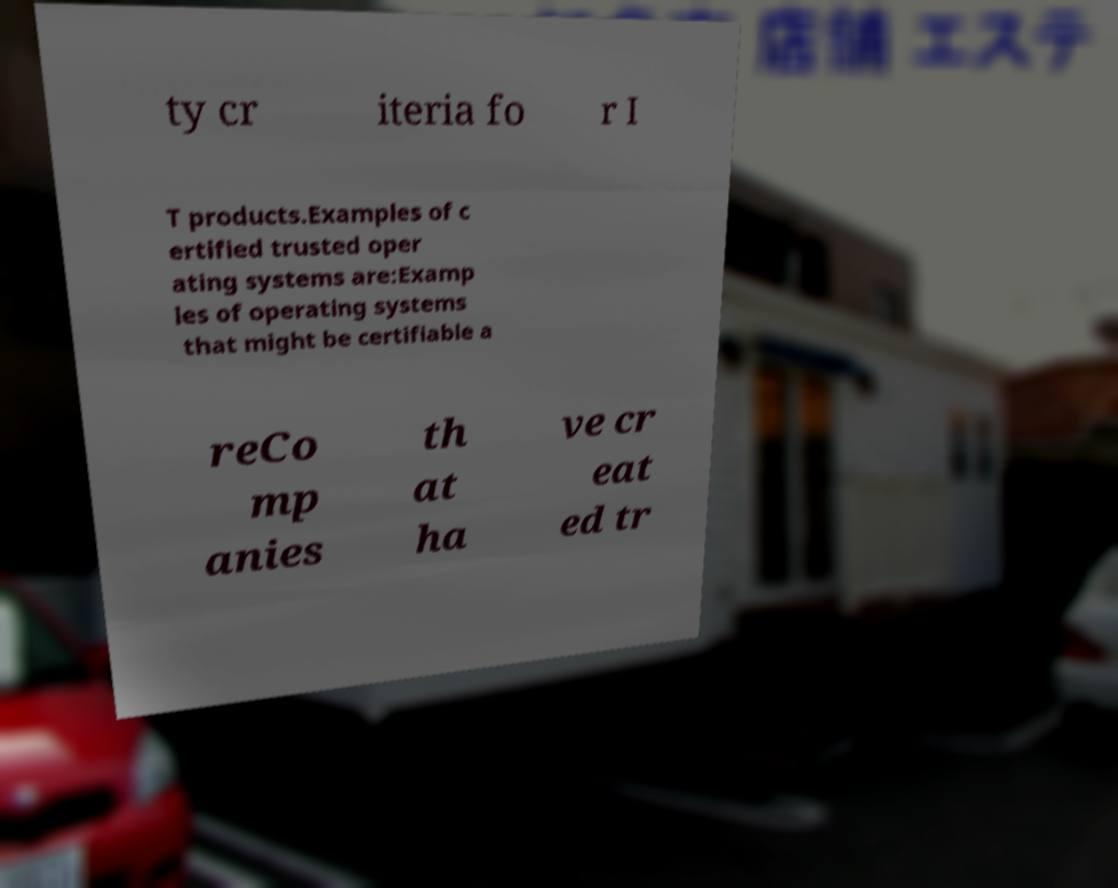Please read and relay the text visible in this image. What does it say? ty cr iteria fo r I T products.Examples of c ertified trusted oper ating systems are:Examp les of operating systems that might be certifiable a reCo mp anies th at ha ve cr eat ed tr 